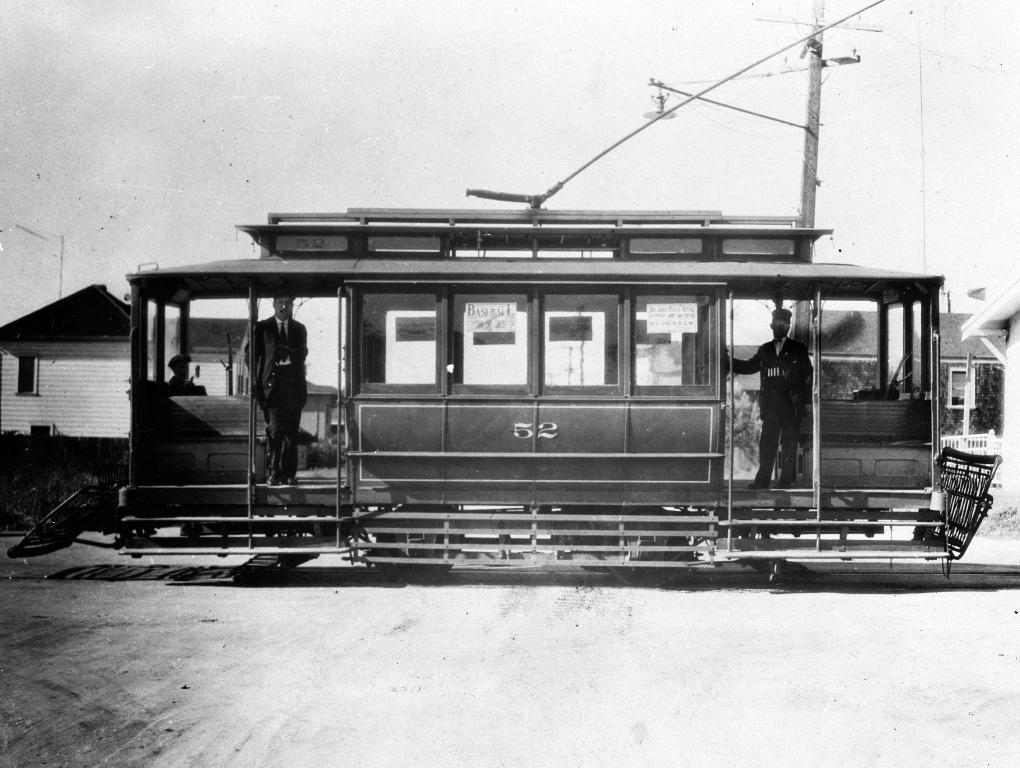Describe this image in one or two sentences. In this picture, we can see an old picture, we can see vehicle and a few people in it, we can see the ground, poles, houses, and the sky. 